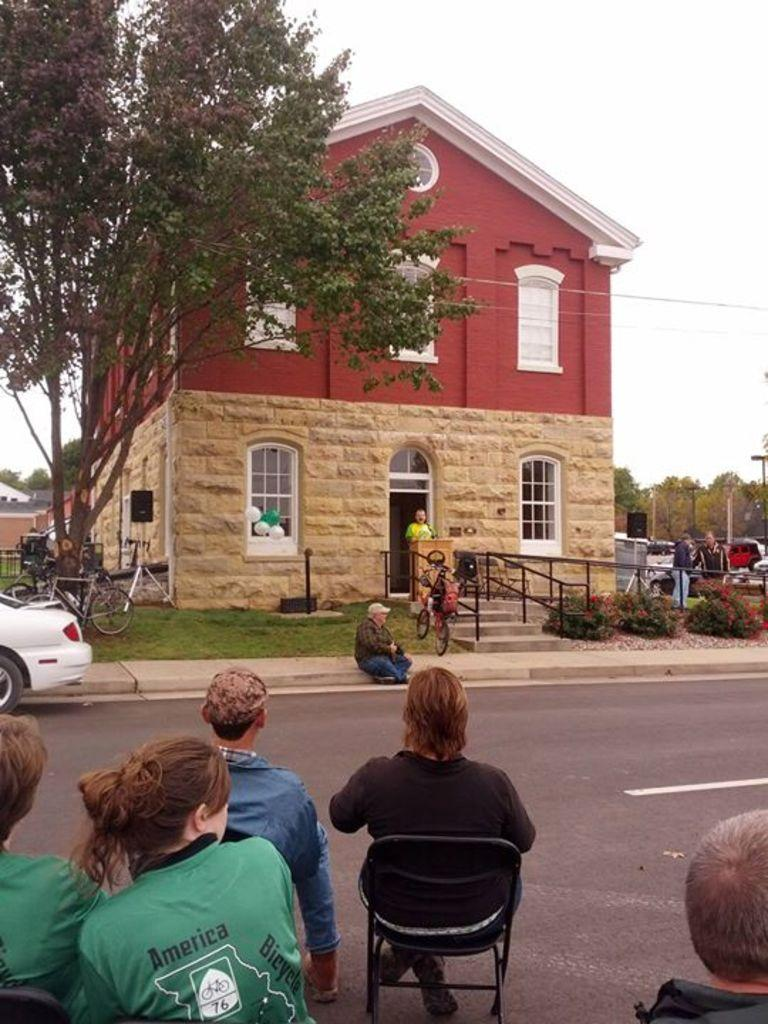How many people are in the image? There is a group of people in the image. What are the people doing in the image? The people are sitting on chairs. Where are the people located in the image? The people are on the road. What else can be seen on the road in the image? There is a car on the road. What is in front of the people on the road? There is a building and a tree in front of the people. What can be seen in the sky in the image? The sky is visible in the image. What type of butter is being used by the people in the image? There is no butter present in the image. Can you tell me how the pigs are interacting with the people in the image? There are no pigs present in the image. 